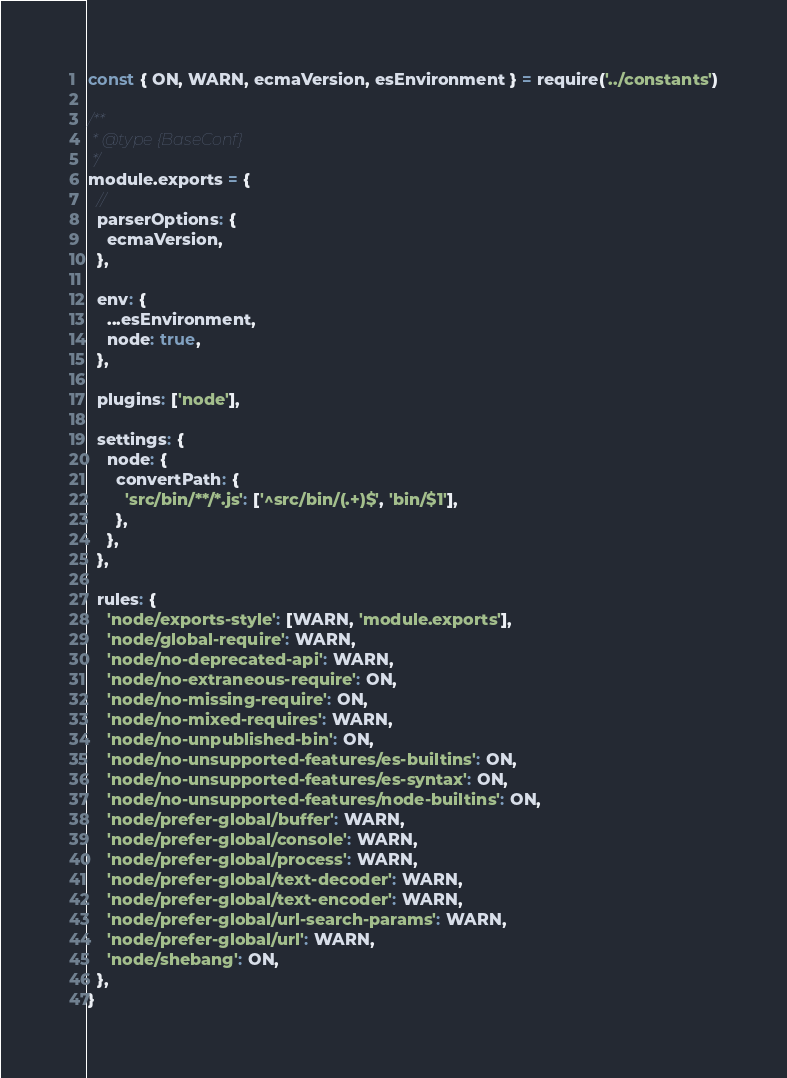<code> <loc_0><loc_0><loc_500><loc_500><_JavaScript_>const { ON, WARN, ecmaVersion, esEnvironment } = require('../constants')

/**
 * @type {BaseConf}
 */
module.exports = {
  //
  parserOptions: {
    ecmaVersion,
  },

  env: {
    ...esEnvironment,
    node: true,
  },

  plugins: ['node'],

  settings: {
    node: {
      convertPath: {
        'src/bin/**/*.js': ['^src/bin/(.+)$', 'bin/$1'],
      },
    },
  },

  rules: {
    'node/exports-style': [WARN, 'module.exports'],
    'node/global-require': WARN,
    'node/no-deprecated-api': WARN,
    'node/no-extraneous-require': ON,
    'node/no-missing-require': ON,
    'node/no-mixed-requires': WARN,
    'node/no-unpublished-bin': ON,
    'node/no-unsupported-features/es-builtins': ON,
    'node/no-unsupported-features/es-syntax': ON,
    'node/no-unsupported-features/node-builtins': ON,
    'node/prefer-global/buffer': WARN,
    'node/prefer-global/console': WARN,
    'node/prefer-global/process': WARN,
    'node/prefer-global/text-decoder': WARN,
    'node/prefer-global/text-encoder': WARN,
    'node/prefer-global/url-search-params': WARN,
    'node/prefer-global/url': WARN,
    'node/shebang': ON,
  },
}
</code> 